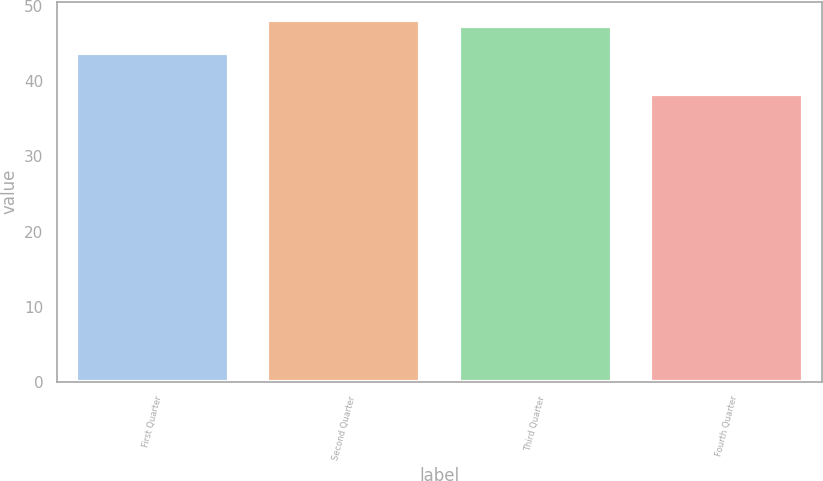Convert chart. <chart><loc_0><loc_0><loc_500><loc_500><bar_chart><fcel>First Quarter<fcel>Second Quarter<fcel>Third Quarter<fcel>Fourth Quarter<nl><fcel>43.78<fcel>48.19<fcel>47.28<fcel>38.36<nl></chart> 